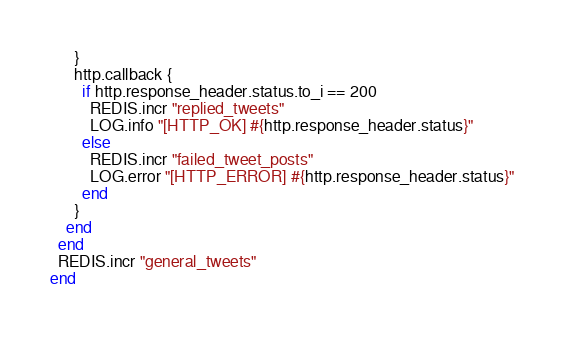Convert code to text. <code><loc_0><loc_0><loc_500><loc_500><_Ruby_>      }
      http.callback {
        if http.response_header.status.to_i == 200
          REDIS.incr "replied_tweets"
          LOG.info "[HTTP_OK] #{http.response_header.status}"
        else
          REDIS.incr "failed_tweet_posts"
          LOG.error "[HTTP_ERROR] #{http.response_header.status}"
        end
      }
    end
  end
  REDIS.incr "general_tweets"
end
</code> 